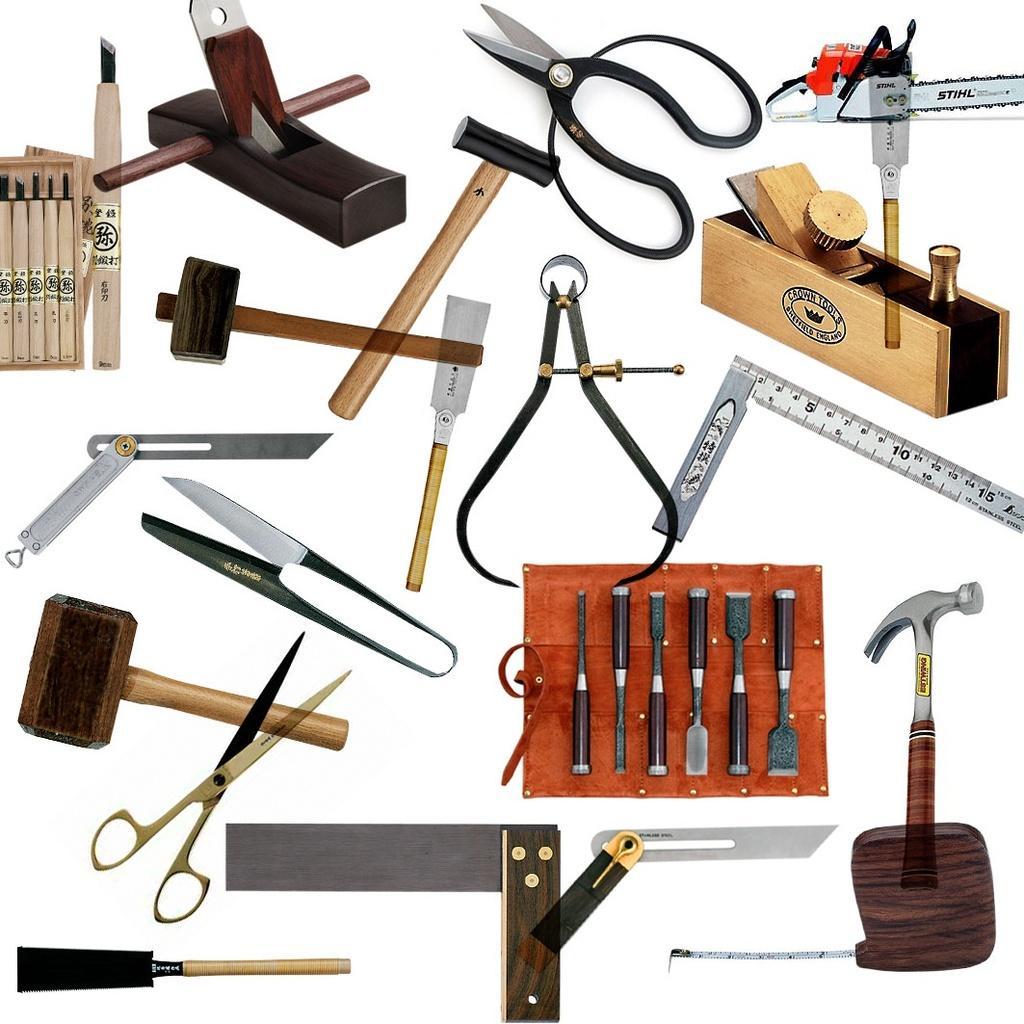In one or two sentences, can you explain what this image depicts? This image consists of some objects. Here I can see hammers, claw hammer, scissor, cutter, scale, box and some other objects. 